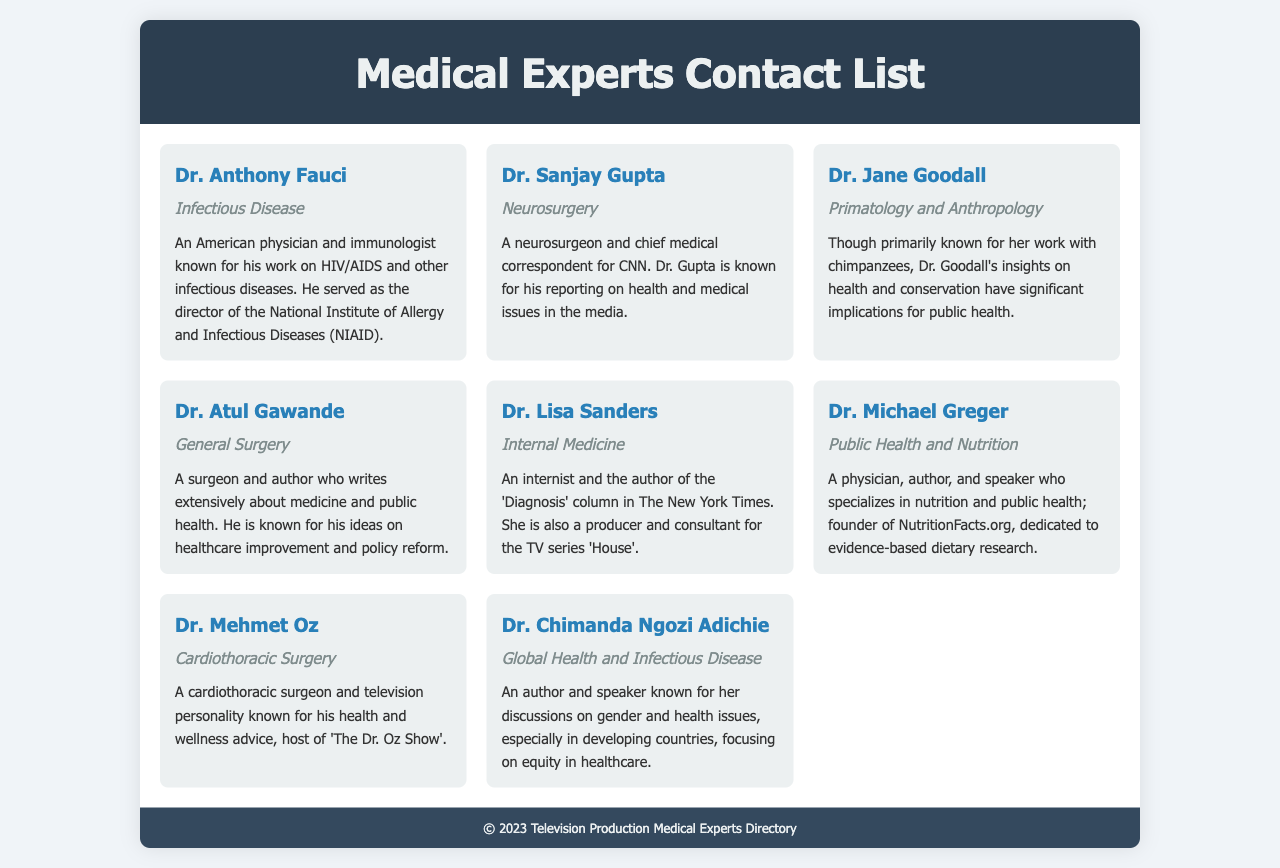What is the specialty of Dr. Anthony Fauci? Dr. Anthony Fauci is categorized under Infectious Disease in the document.
Answer: Infectious Disease Who is the chief medical correspondent for CNN? The document states that Dr. Sanjay Gupta is the chief medical correspondent for CNN.
Answer: Dr. Sanjay Gupta Which expert is known for their work with chimpanzees? Dr. Jane Goodall is primarily known for her work with chimpanzees as per the document.
Answer: Dr. Jane Goodall What specialty does Dr. Mehmet Oz practice? The document lists Dr. Mehmet Oz as a cardiothoracic surgeon.
Answer: Cardiothoracic Surgery Who authored the 'Diagnosis' column in The New York Times? According to the document, Dr. Lisa Sanders is the author of the 'Diagnosis' column in The New York Times.
Answer: Dr. Lisa Sanders Which expert focuses on nutrition and public health? Dr. Michael Greger specializes in public health and nutrition according to the document.
Answer: Public Health and Nutrition What is Dr. Atul Gawande known for? The document states that Dr. Atul Gawande is known for writing about medicine and public health.
Answer: Medicine and Public Health Who is recognized for discussions on gender and health issues? The document mentions Dr. Chimanda Ngozi Adichie for her discussions on gender and health issues.
Answer: Dr. Chimanda Ngozi Adichie How many medical experts are listed in the document? There are eight experts presented in the contact list according to the document.
Answer: Eight 